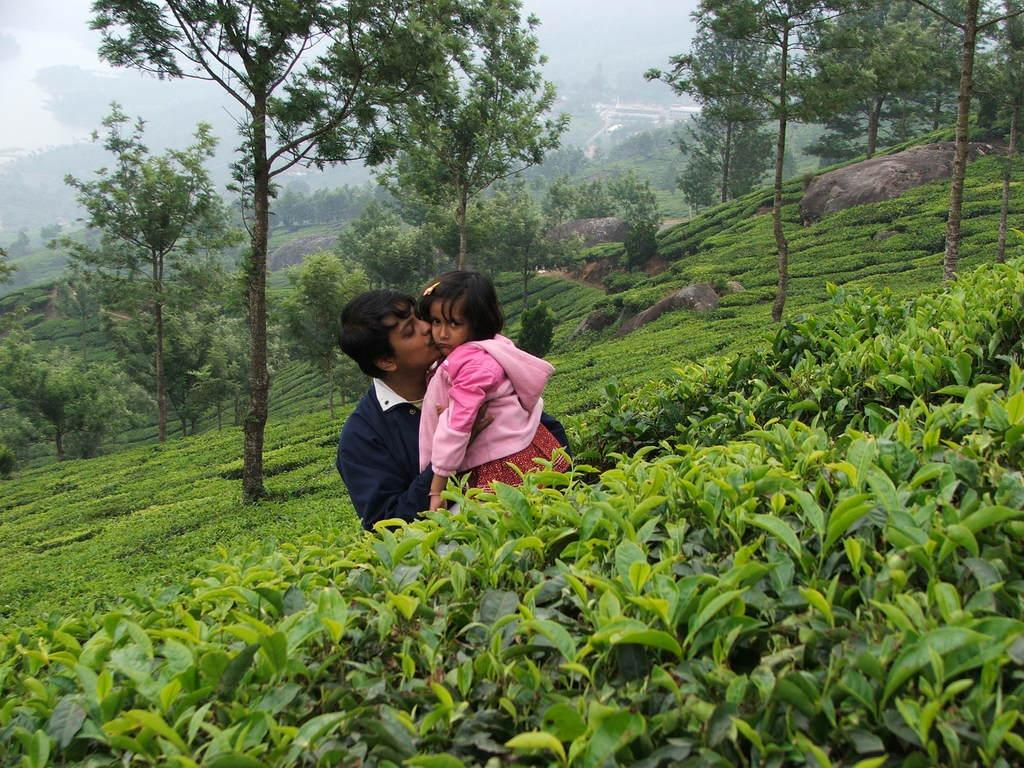Who is the main subject in the image? There is a man in the image. What is the man doing in the image? The man is holding a girl. What can be seen in the background of the image? There are plants, trees, and fog visible in the background of the image. What type of produce is the man selling in the image? There is no produce present in the image; the man is holding a girl. What type of coach can be seen in the background of the image? There is no coach present in the image; the background features plants, trees, and fog. 